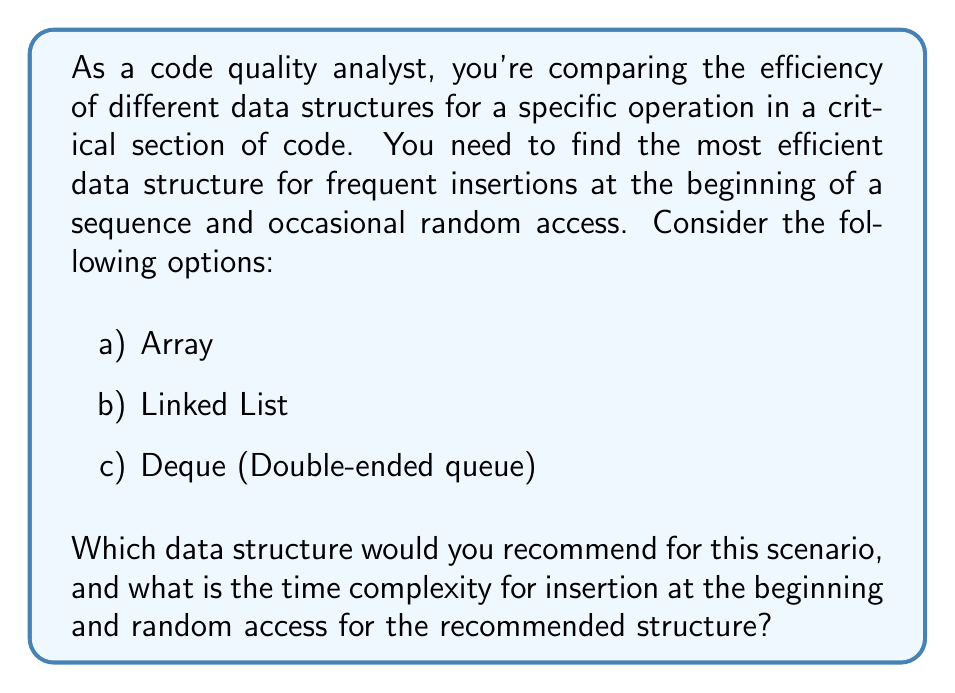What is the answer to this math problem? To answer this question, we need to analyze the time complexities of insertion at the beginning and random access for each data structure:

1. Array:
   - Insertion at the beginning: $O(n)$, where $n$ is the number of elements
   - Random access: $O(1)$

2. Linked List:
   - Insertion at the beginning: $O(1)$
   - Random access: $O(n)$, where $n$ is the number of elements

3. Deque (Double-ended queue):
   - Insertion at the beginning: $O(1)$
   - Random access: $O(1)$

For frequent insertions at the beginning, we want to avoid the $O(n)$ time complexity of arrays. This eliminates option (a).

Both Linked List and Deque offer $O(1)$ insertion at the beginning, which is ideal for our frequent insertion requirement.

However, for occasional random access, Linked List performs poorly with $O(n)$ time complexity, while Deque maintains $O(1)$ time complexity.

Therefore, the Deque (Double-ended queue) is the most efficient data structure for this scenario, as it offers $O(1)$ time complexity for both frequent insertions at the beginning and occasional random access.

In practice, a Deque is often implemented using a combination of a doubly-linked list and an array, allowing for efficient operations at both ends and constant-time random access.
Answer: The recommended data structure is Deque (Double-ended queue). The time complexity for insertion at the beginning is $O(1)$, and the time complexity for random access is also $O(1)$. 